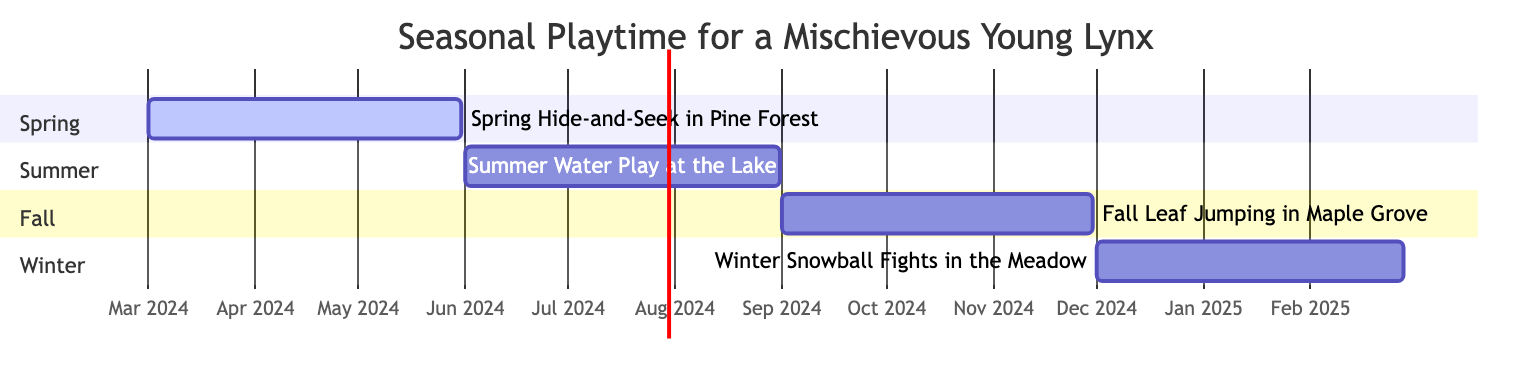What activity starts in March? The diagram indicates that "Spring Hide-and-Seek in Pine Forest" starts on March 1st. This is the only activity that begins in March in the Gantt chart.
Answer: Spring Hide-and-Seek in Pine Forest How many activities take place in summer? The Gantt chart shows one activity labeled "Summer Water Play at the Lake," which occurs from June 1st to August 31st. This indicates that there is a total of one activity during the summer months.
Answer: 1 What is the duration of "Fall Leaf Jumping in Maple Grove"? "Fall Leaf Jumping in Maple Grove" starts on September 1st and ends on November 30th. The duration can be calculated from these dates, which spans three months in total.
Answer: 3 months Which activity overlaps with winter activities? By examining the dates, "Winter Snowball Fights in the Meadow" starts on December 1st, but since it does not overlap with any of the other activities, no other activities overlap with winter activities.
Answer: No What is the end date of the Spring activity? The spring activity "Spring Hide-and-Seek in Pine Forest" ends on May 31st, according to the data in the diagram. This is clearly indicated within the specific timeline for spring.
Answer: May 31, 2024 Which season's activity ends the latest? The Gantt chart shows "Winter Snowball Fights in the Meadow," which ends on February 28, 2025. This indicates that winter has the latest ending compared to other seasons.
Answer: Winter What activity is active during the first half of 2024? The diagram shows that "Spring Hide-and-Seek in Pine Forest" runs from March 1 to May 31, and "Summer Water Play at the Lake" begins on June 1. This indicates that the only activity active during the first half of 2024 is in spring.
Answer: Spring Hide-and-Seek in Pine Forest How many sections are there in the Gantt chart? The Gantt chart has four different sections: Spring, Summer, Fall, and Winter. Each section represents a different seasonal activity, totaling four sections.
Answer: 4 